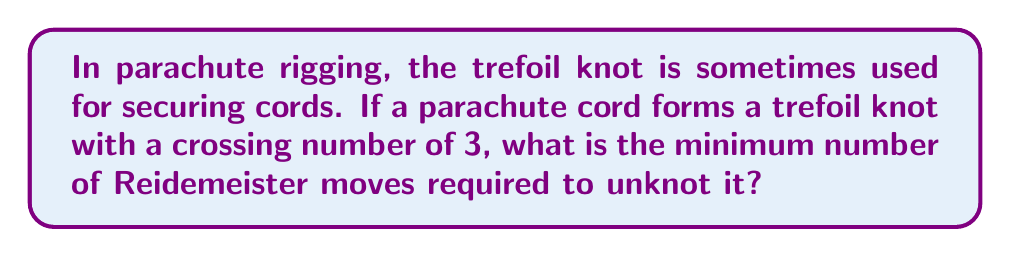Show me your answer to this math problem. To solve this problem, we need to understand the properties of the trefoil knot and Reidemeister moves:

1. The trefoil knot is the simplest non-trivial knot, with a crossing number of 3.

2. Reidemeister moves are operations that can be performed on a knot diagram without changing the knot type. There are three types of Reidemeister moves:
   - Type I: Twist or untwist a strand
   - Type II: Move one strand completely over or under another
   - Type III: Move a strand over or under a crossing

3. The trefoil knot is a prime knot, meaning it cannot be decomposed into simpler knots. It is also chiral, which means it is not equivalent to its mirror image.

4. To unknot the trefoil, we need to perform a series of Reidemeister moves that will transform it into a simple loop (the unknot).

5. The minimum number of Reidemeister moves required to unknot a trefoil is 7. This sequence typically involves:
   - One Type I move
   - Three Type II moves
   - Three Type III moves

6. The general sequence to unknot a trefoil is:
   $$\text{Trefoil} \xrightarrow{\text{Type I}} \xrightarrow{\text{Type II}} \xrightarrow{\text{Type III}} \xrightarrow{\text{Type II}} \xrightarrow{\text{Type III}} \xrightarrow{\text{Type II}} \xrightarrow{\text{Type III}} \text{Unknot}$$

7. It's important to note that while there may be other sequences of moves that can unknot the trefoil, 7 is the minimum number required.

This knowledge of knot theory is crucial for parachute riggers, as it helps ensure the safety and reliability of parachute systems used by airborne soldiers.
Answer: 7 Reidemeister moves 